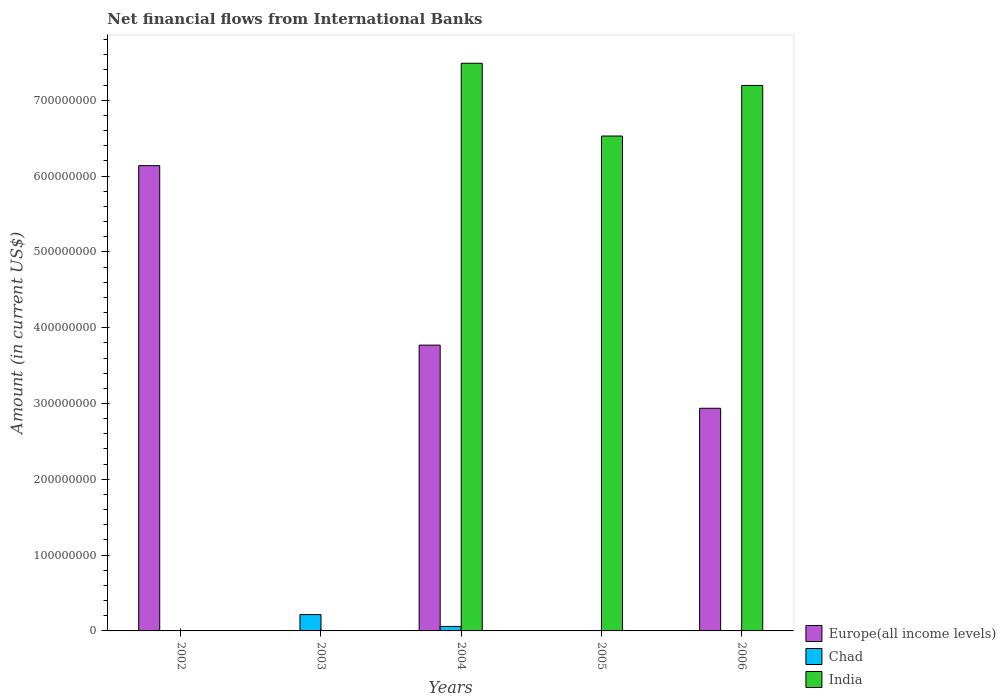How many different coloured bars are there?
Ensure brevity in your answer.  3. Are the number of bars per tick equal to the number of legend labels?
Provide a succinct answer. No. Are the number of bars on each tick of the X-axis equal?
Keep it short and to the point. No. What is the label of the 2nd group of bars from the left?
Provide a short and direct response. 2003. In how many cases, is the number of bars for a given year not equal to the number of legend labels?
Offer a terse response. 4. Across all years, what is the maximum net financial aid flows in Europe(all income levels)?
Provide a succinct answer. 6.14e+08. Across all years, what is the minimum net financial aid flows in Chad?
Offer a very short reply. 0. What is the total net financial aid flows in India in the graph?
Your answer should be compact. 2.12e+09. What is the difference between the net financial aid flows in India in 2005 and that in 2006?
Your answer should be compact. -6.67e+07. What is the difference between the net financial aid flows in Chad in 2003 and the net financial aid flows in Europe(all income levels) in 2006?
Make the answer very short. -2.72e+08. What is the average net financial aid flows in Europe(all income levels) per year?
Make the answer very short. 2.57e+08. In the year 2004, what is the difference between the net financial aid flows in Chad and net financial aid flows in India?
Your response must be concise. -7.43e+08. In how many years, is the net financial aid flows in Europe(all income levels) greater than 620000000 US$?
Offer a terse response. 0. What is the ratio of the net financial aid flows in Europe(all income levels) in 2002 to that in 2006?
Your answer should be compact. 2.09. Is the net financial aid flows in India in 2004 less than that in 2005?
Your answer should be compact. No. What is the difference between the highest and the second highest net financial aid flows in Chad?
Offer a very short reply. 1.56e+07. What is the difference between the highest and the lowest net financial aid flows in India?
Offer a terse response. 7.49e+08. In how many years, is the net financial aid flows in Chad greater than the average net financial aid flows in Chad taken over all years?
Offer a terse response. 2. How many bars are there?
Provide a short and direct response. 9. Are all the bars in the graph horizontal?
Offer a terse response. No. How many years are there in the graph?
Provide a short and direct response. 5. Does the graph contain any zero values?
Your answer should be compact. Yes. Does the graph contain grids?
Ensure brevity in your answer.  No. Where does the legend appear in the graph?
Keep it short and to the point. Bottom right. How are the legend labels stacked?
Give a very brief answer. Vertical. What is the title of the graph?
Your answer should be very brief. Net financial flows from International Banks. What is the label or title of the X-axis?
Your answer should be compact. Years. What is the label or title of the Y-axis?
Your answer should be very brief. Amount (in current US$). What is the Amount (in current US$) of Europe(all income levels) in 2002?
Give a very brief answer. 6.14e+08. What is the Amount (in current US$) of Chad in 2002?
Offer a very short reply. 2.76e+05. What is the Amount (in current US$) in Chad in 2003?
Offer a terse response. 2.16e+07. What is the Amount (in current US$) in India in 2003?
Your answer should be compact. 0. What is the Amount (in current US$) of Europe(all income levels) in 2004?
Offer a very short reply. 3.77e+08. What is the Amount (in current US$) in Chad in 2004?
Give a very brief answer. 5.92e+06. What is the Amount (in current US$) of India in 2004?
Your response must be concise. 7.49e+08. What is the Amount (in current US$) in India in 2005?
Provide a succinct answer. 6.53e+08. What is the Amount (in current US$) of Europe(all income levels) in 2006?
Keep it short and to the point. 2.94e+08. What is the Amount (in current US$) in Chad in 2006?
Make the answer very short. 0. What is the Amount (in current US$) in India in 2006?
Provide a short and direct response. 7.20e+08. Across all years, what is the maximum Amount (in current US$) in Europe(all income levels)?
Provide a short and direct response. 6.14e+08. Across all years, what is the maximum Amount (in current US$) of Chad?
Provide a short and direct response. 2.16e+07. Across all years, what is the maximum Amount (in current US$) in India?
Your answer should be compact. 7.49e+08. Across all years, what is the minimum Amount (in current US$) of Europe(all income levels)?
Offer a terse response. 0. Across all years, what is the minimum Amount (in current US$) in India?
Keep it short and to the point. 0. What is the total Amount (in current US$) in Europe(all income levels) in the graph?
Give a very brief answer. 1.28e+09. What is the total Amount (in current US$) of Chad in the graph?
Provide a succinct answer. 2.78e+07. What is the total Amount (in current US$) in India in the graph?
Your answer should be very brief. 2.12e+09. What is the difference between the Amount (in current US$) in Chad in 2002 and that in 2003?
Provide a short and direct response. -2.13e+07. What is the difference between the Amount (in current US$) in Europe(all income levels) in 2002 and that in 2004?
Offer a very short reply. 2.37e+08. What is the difference between the Amount (in current US$) of Chad in 2002 and that in 2004?
Give a very brief answer. -5.64e+06. What is the difference between the Amount (in current US$) in Europe(all income levels) in 2002 and that in 2006?
Your answer should be compact. 3.20e+08. What is the difference between the Amount (in current US$) in Chad in 2003 and that in 2004?
Ensure brevity in your answer.  1.56e+07. What is the difference between the Amount (in current US$) of India in 2004 and that in 2005?
Keep it short and to the point. 9.60e+07. What is the difference between the Amount (in current US$) of Europe(all income levels) in 2004 and that in 2006?
Your answer should be very brief. 8.33e+07. What is the difference between the Amount (in current US$) in India in 2004 and that in 2006?
Your answer should be very brief. 2.93e+07. What is the difference between the Amount (in current US$) in India in 2005 and that in 2006?
Offer a terse response. -6.67e+07. What is the difference between the Amount (in current US$) in Europe(all income levels) in 2002 and the Amount (in current US$) in Chad in 2003?
Your answer should be very brief. 5.92e+08. What is the difference between the Amount (in current US$) in Europe(all income levels) in 2002 and the Amount (in current US$) in Chad in 2004?
Ensure brevity in your answer.  6.08e+08. What is the difference between the Amount (in current US$) in Europe(all income levels) in 2002 and the Amount (in current US$) in India in 2004?
Give a very brief answer. -1.35e+08. What is the difference between the Amount (in current US$) of Chad in 2002 and the Amount (in current US$) of India in 2004?
Your answer should be compact. -7.49e+08. What is the difference between the Amount (in current US$) in Europe(all income levels) in 2002 and the Amount (in current US$) in India in 2005?
Your answer should be compact. -3.91e+07. What is the difference between the Amount (in current US$) in Chad in 2002 and the Amount (in current US$) in India in 2005?
Ensure brevity in your answer.  -6.53e+08. What is the difference between the Amount (in current US$) of Europe(all income levels) in 2002 and the Amount (in current US$) of India in 2006?
Provide a succinct answer. -1.06e+08. What is the difference between the Amount (in current US$) in Chad in 2002 and the Amount (in current US$) in India in 2006?
Your response must be concise. -7.19e+08. What is the difference between the Amount (in current US$) in Chad in 2003 and the Amount (in current US$) in India in 2004?
Your answer should be very brief. -7.27e+08. What is the difference between the Amount (in current US$) in Chad in 2003 and the Amount (in current US$) in India in 2005?
Give a very brief answer. -6.31e+08. What is the difference between the Amount (in current US$) of Chad in 2003 and the Amount (in current US$) of India in 2006?
Your answer should be very brief. -6.98e+08. What is the difference between the Amount (in current US$) in Europe(all income levels) in 2004 and the Amount (in current US$) in India in 2005?
Give a very brief answer. -2.76e+08. What is the difference between the Amount (in current US$) of Chad in 2004 and the Amount (in current US$) of India in 2005?
Your response must be concise. -6.47e+08. What is the difference between the Amount (in current US$) in Europe(all income levels) in 2004 and the Amount (in current US$) in India in 2006?
Keep it short and to the point. -3.43e+08. What is the difference between the Amount (in current US$) in Chad in 2004 and the Amount (in current US$) in India in 2006?
Your answer should be compact. -7.14e+08. What is the average Amount (in current US$) of Europe(all income levels) per year?
Ensure brevity in your answer.  2.57e+08. What is the average Amount (in current US$) in Chad per year?
Your answer should be very brief. 5.55e+06. What is the average Amount (in current US$) in India per year?
Provide a succinct answer. 4.24e+08. In the year 2002, what is the difference between the Amount (in current US$) in Europe(all income levels) and Amount (in current US$) in Chad?
Provide a short and direct response. 6.13e+08. In the year 2004, what is the difference between the Amount (in current US$) in Europe(all income levels) and Amount (in current US$) in Chad?
Your answer should be very brief. 3.71e+08. In the year 2004, what is the difference between the Amount (in current US$) in Europe(all income levels) and Amount (in current US$) in India?
Offer a terse response. -3.72e+08. In the year 2004, what is the difference between the Amount (in current US$) in Chad and Amount (in current US$) in India?
Provide a succinct answer. -7.43e+08. In the year 2006, what is the difference between the Amount (in current US$) in Europe(all income levels) and Amount (in current US$) in India?
Provide a short and direct response. -4.26e+08. What is the ratio of the Amount (in current US$) of Chad in 2002 to that in 2003?
Ensure brevity in your answer.  0.01. What is the ratio of the Amount (in current US$) in Europe(all income levels) in 2002 to that in 2004?
Keep it short and to the point. 1.63. What is the ratio of the Amount (in current US$) of Chad in 2002 to that in 2004?
Provide a short and direct response. 0.05. What is the ratio of the Amount (in current US$) in Europe(all income levels) in 2002 to that in 2006?
Offer a very short reply. 2.09. What is the ratio of the Amount (in current US$) of Chad in 2003 to that in 2004?
Your answer should be compact. 3.64. What is the ratio of the Amount (in current US$) of India in 2004 to that in 2005?
Your answer should be very brief. 1.15. What is the ratio of the Amount (in current US$) in Europe(all income levels) in 2004 to that in 2006?
Offer a very short reply. 1.28. What is the ratio of the Amount (in current US$) in India in 2004 to that in 2006?
Provide a short and direct response. 1.04. What is the ratio of the Amount (in current US$) of India in 2005 to that in 2006?
Keep it short and to the point. 0.91. What is the difference between the highest and the second highest Amount (in current US$) in Europe(all income levels)?
Make the answer very short. 2.37e+08. What is the difference between the highest and the second highest Amount (in current US$) in Chad?
Your response must be concise. 1.56e+07. What is the difference between the highest and the second highest Amount (in current US$) in India?
Your answer should be compact. 2.93e+07. What is the difference between the highest and the lowest Amount (in current US$) of Europe(all income levels)?
Your answer should be compact. 6.14e+08. What is the difference between the highest and the lowest Amount (in current US$) of Chad?
Provide a short and direct response. 2.16e+07. What is the difference between the highest and the lowest Amount (in current US$) of India?
Your response must be concise. 7.49e+08. 